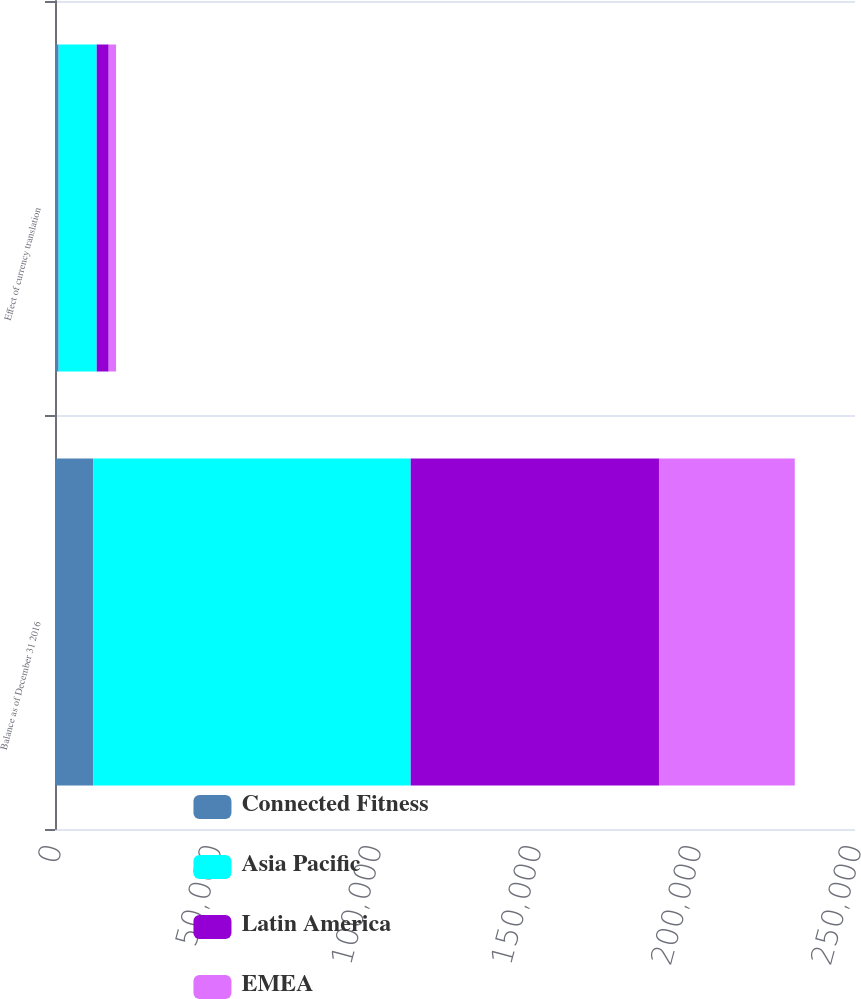<chart> <loc_0><loc_0><loc_500><loc_500><stacked_bar_chart><ecel><fcel>Balance as of December 31 2016<fcel>Effect of currency translation<nl><fcel>Connected Fitness<fcel>11910<fcel>1132<nl><fcel>Asia Pacific<fcel>99245<fcel>11910<nl><fcel>Latin America<fcel>77586<fcel>3737<nl><fcel>EMEA<fcel>42436<fcel>2305<nl></chart> 